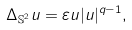Convert formula to latex. <formula><loc_0><loc_0><loc_500><loc_500>\Delta _ { { \mathbb { S } } ^ { 2 } } u = \varepsilon u | u | ^ { q - 1 } ,</formula> 